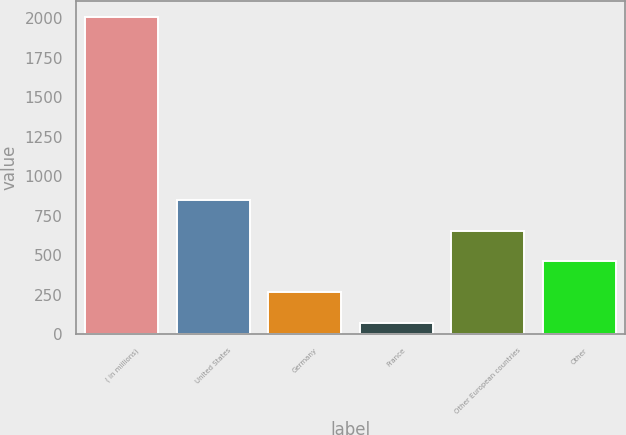Convert chart to OTSL. <chart><loc_0><loc_0><loc_500><loc_500><bar_chart><fcel>( in millions)<fcel>United States<fcel>Germany<fcel>France<fcel>Other European countries<fcel>Other<nl><fcel>2006<fcel>846.62<fcel>266.93<fcel>73.7<fcel>653.39<fcel>460.16<nl></chart> 